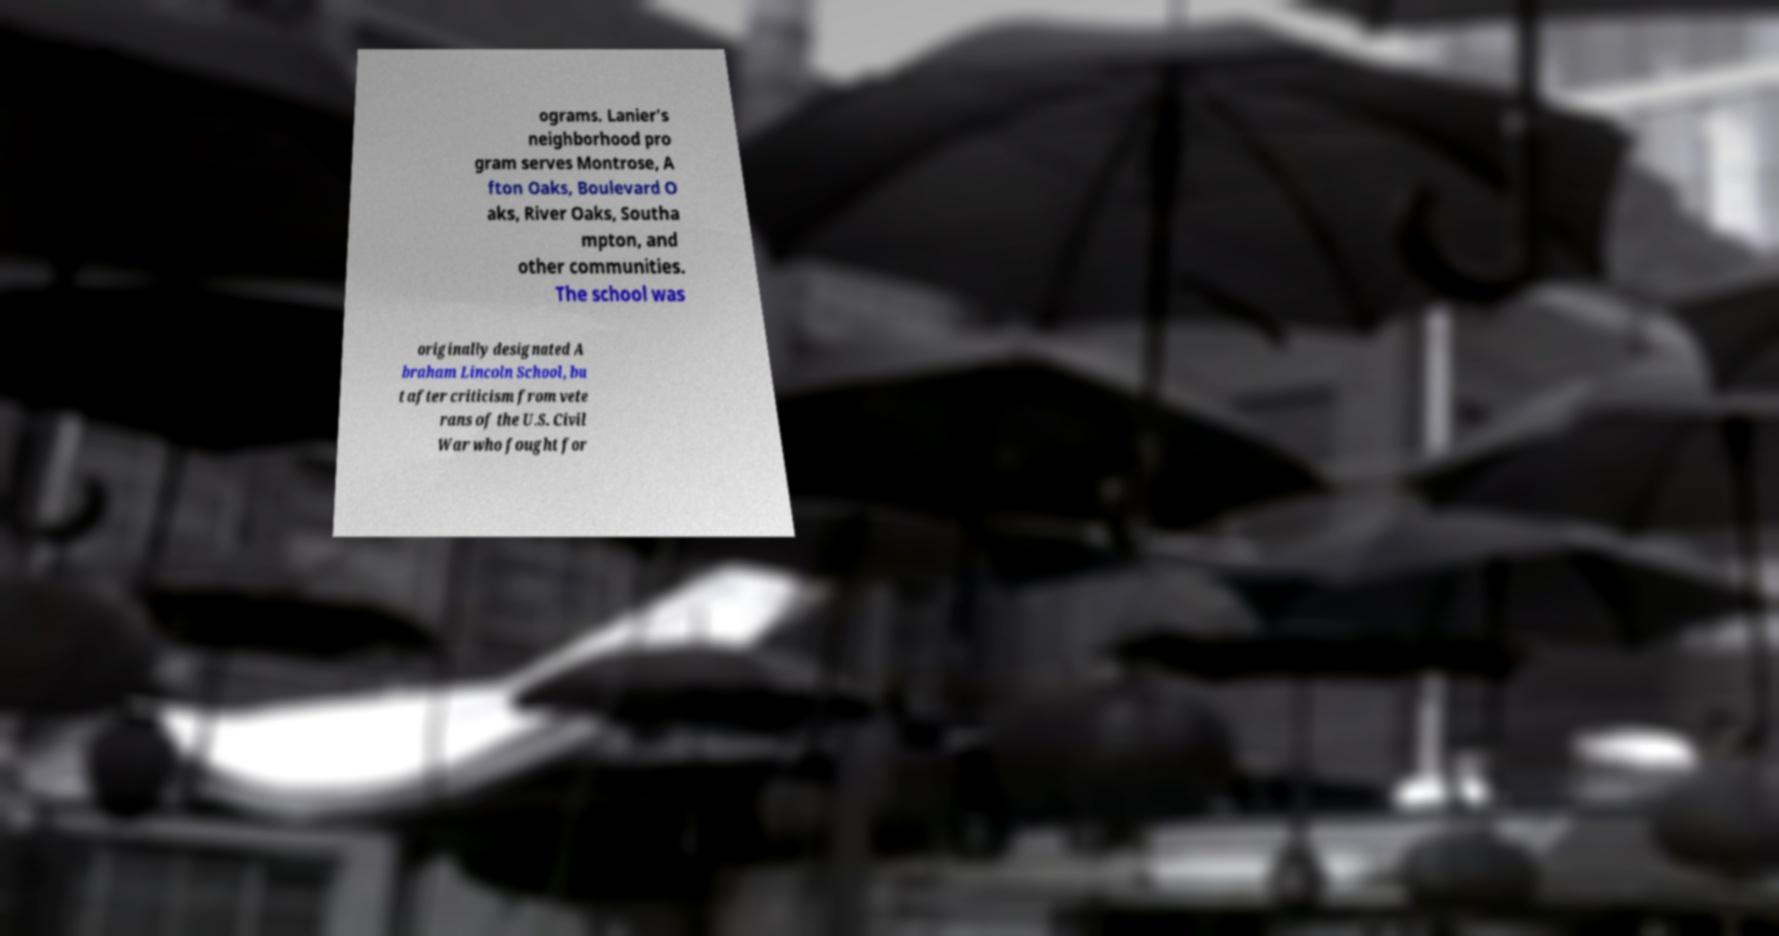There's text embedded in this image that I need extracted. Can you transcribe it verbatim? ograms. Lanier's neighborhood pro gram serves Montrose, A fton Oaks, Boulevard O aks, River Oaks, Southa mpton, and other communities. The school was originally designated A braham Lincoln School, bu t after criticism from vete rans of the U.S. Civil War who fought for 